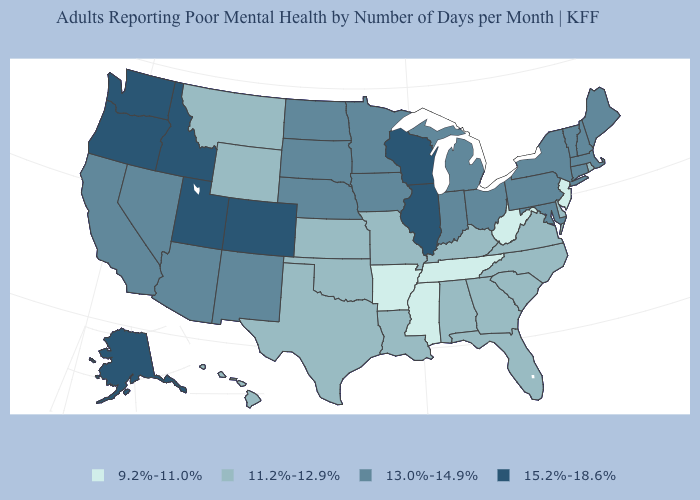Among the states that border Montana , which have the lowest value?
Concise answer only. Wyoming. Does the map have missing data?
Keep it brief. No. What is the value of Utah?
Answer briefly. 15.2%-18.6%. Name the states that have a value in the range 15.2%-18.6%?
Quick response, please. Alaska, Colorado, Idaho, Illinois, Oregon, Utah, Washington, Wisconsin. What is the value of Connecticut?
Be succinct. 13.0%-14.9%. Among the states that border Louisiana , which have the lowest value?
Give a very brief answer. Arkansas, Mississippi. Among the states that border Texas , which have the highest value?
Keep it brief. New Mexico. What is the value of Florida?
Keep it brief. 11.2%-12.9%. Among the states that border South Carolina , which have the lowest value?
Quick response, please. Georgia, North Carolina. Does New Mexico have the lowest value in the West?
Quick response, please. No. How many symbols are there in the legend?
Answer briefly. 4. Which states hav the highest value in the South?
Be succinct. Maryland. Does New York have a lower value than Illinois?
Answer briefly. Yes. What is the value of Wyoming?
Keep it brief. 11.2%-12.9%. What is the value of Rhode Island?
Concise answer only. 11.2%-12.9%. 